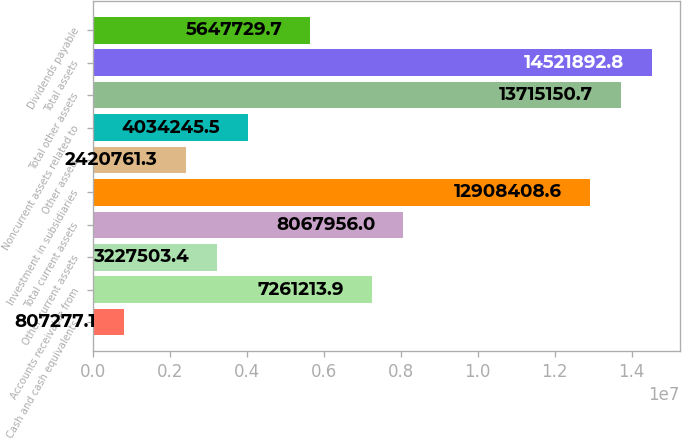Convert chart. <chart><loc_0><loc_0><loc_500><loc_500><bar_chart><fcel>Cash and cash equivalents<fcel>Accounts receivable from<fcel>Other current assets<fcel>Total current assets<fcel>Investment in subsidiaries<fcel>Other assets<fcel>Noncurrent assets related to<fcel>Total other assets<fcel>Total assets<fcel>Dividends payable<nl><fcel>807277<fcel>7.26121e+06<fcel>3.2275e+06<fcel>8.06796e+06<fcel>1.29084e+07<fcel>2.42076e+06<fcel>4.03425e+06<fcel>1.37152e+07<fcel>1.45219e+07<fcel>5.64773e+06<nl></chart> 